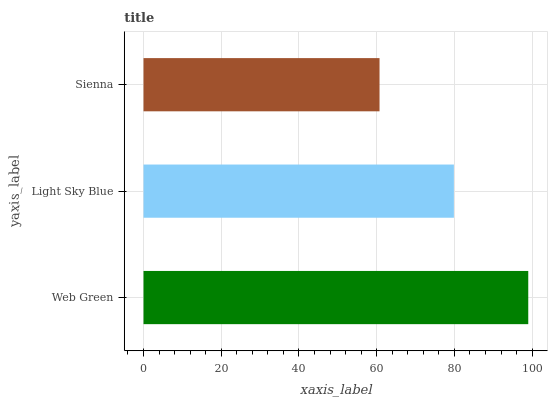Is Sienna the minimum?
Answer yes or no. Yes. Is Web Green the maximum?
Answer yes or no. Yes. Is Light Sky Blue the minimum?
Answer yes or no. No. Is Light Sky Blue the maximum?
Answer yes or no. No. Is Web Green greater than Light Sky Blue?
Answer yes or no. Yes. Is Light Sky Blue less than Web Green?
Answer yes or no. Yes. Is Light Sky Blue greater than Web Green?
Answer yes or no. No. Is Web Green less than Light Sky Blue?
Answer yes or no. No. Is Light Sky Blue the high median?
Answer yes or no. Yes. Is Light Sky Blue the low median?
Answer yes or no. Yes. Is Web Green the high median?
Answer yes or no. No. Is Web Green the low median?
Answer yes or no. No. 